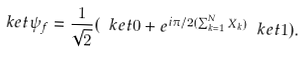<formula> <loc_0><loc_0><loc_500><loc_500>\ k e t { \psi _ { f } } = \frac { 1 } { \sqrt { 2 } } ( \ k e t { 0 } + e ^ { i \pi / 2 ( \sum _ { k = 1 } ^ { N } X _ { k } ) } \ k e t { 1 } ) .</formula> 